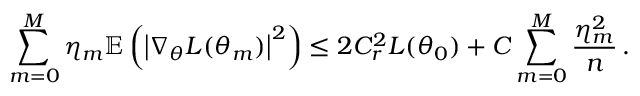<formula> <loc_0><loc_0><loc_500><loc_500>\sum _ { m = 0 } ^ { M } \eta _ { m } \mathbb { E } \left ( \left | \nabla _ { \theta } L ( \theta _ { m } ) \right | ^ { 2 } \right ) \leq 2 C _ { r } ^ { 2 } L ( \theta _ { 0 } ) + C \sum _ { m = 0 } ^ { M } \frac { \eta _ { m } ^ { 2 } } { n } \, .</formula> 